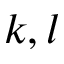<formula> <loc_0><loc_0><loc_500><loc_500>k , l</formula> 